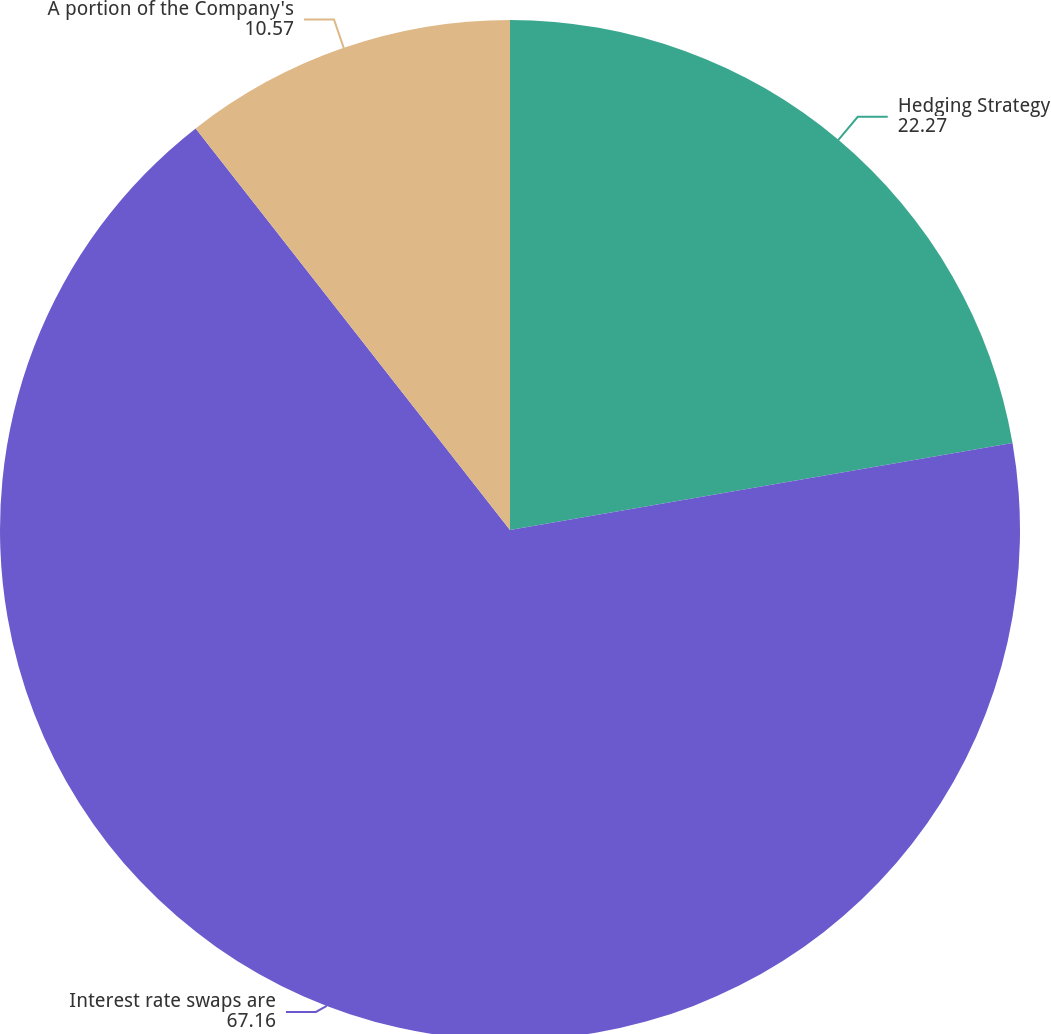Convert chart. <chart><loc_0><loc_0><loc_500><loc_500><pie_chart><fcel>Hedging Strategy<fcel>Interest rate swaps are<fcel>A portion of the Company's<nl><fcel>22.27%<fcel>67.16%<fcel>10.57%<nl></chart> 